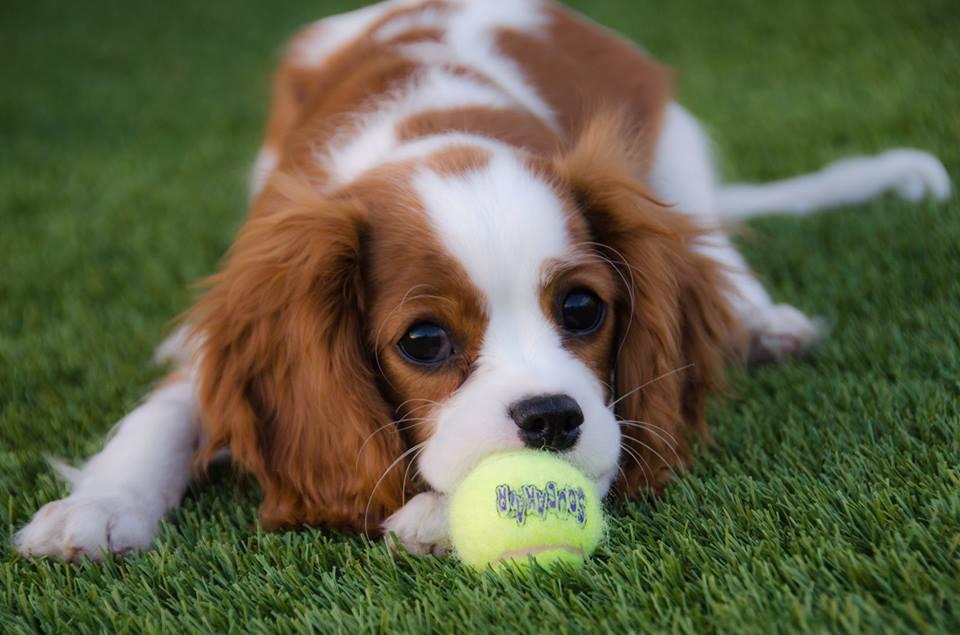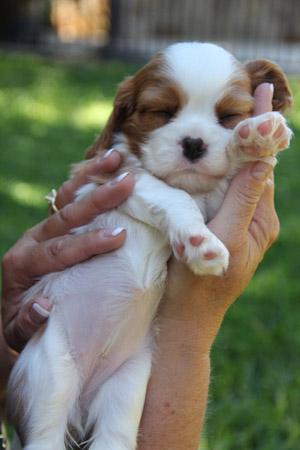The first image is the image on the left, the second image is the image on the right. For the images displayed, is the sentence "Someone is holding up at least one of the puppies." factually correct? Answer yes or no. Yes. The first image is the image on the left, the second image is the image on the right. Given the left and right images, does the statement "Human hands hold at least one puppy in one image." hold true? Answer yes or no. Yes. 